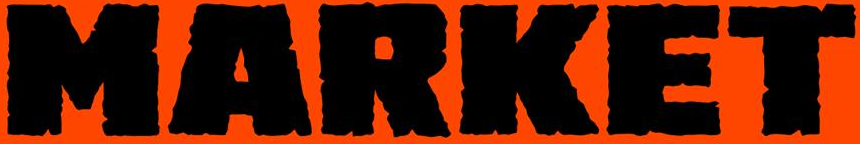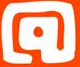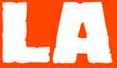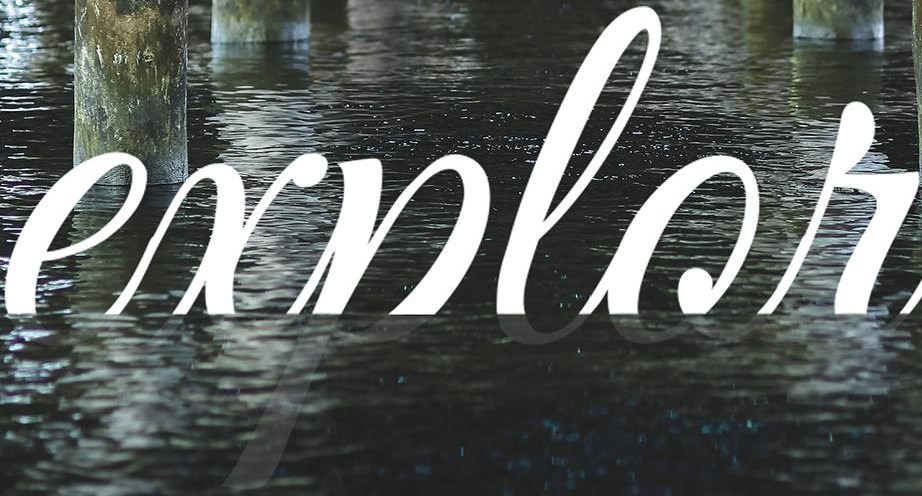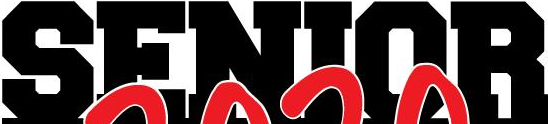Transcribe the words shown in these images in order, separated by a semicolon. MARKET; @; LA; explor; SENIOR 